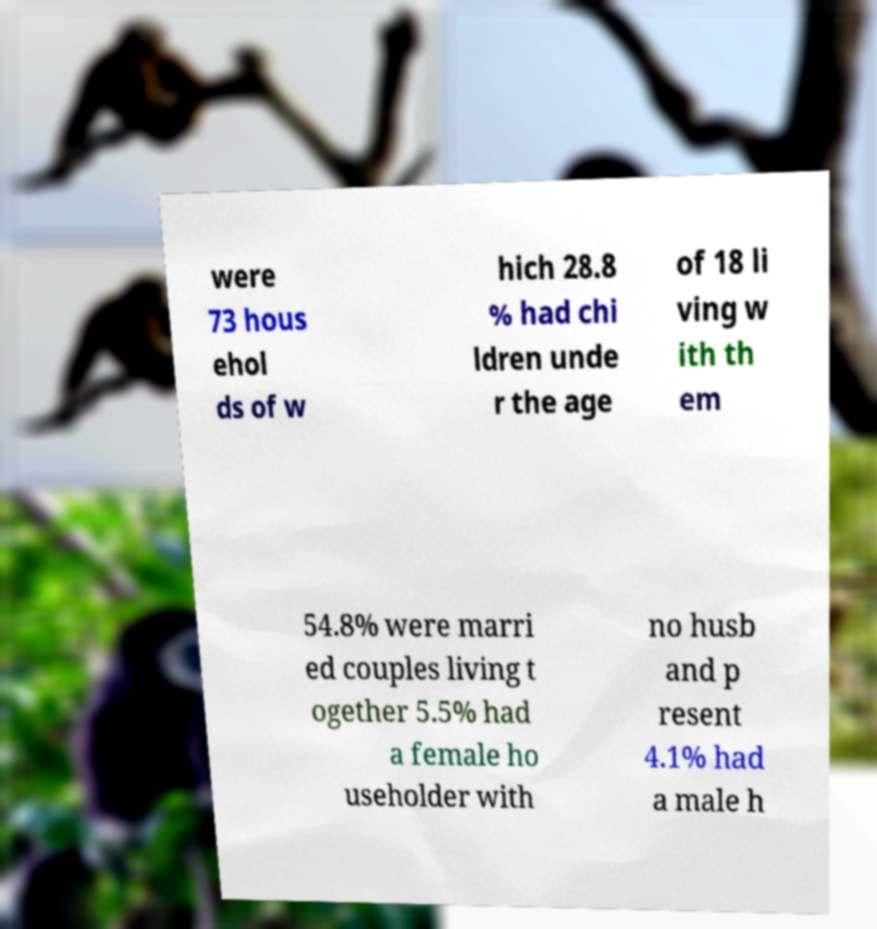Can you accurately transcribe the text from the provided image for me? were 73 hous ehol ds of w hich 28.8 % had chi ldren unde r the age of 18 li ving w ith th em 54.8% were marri ed couples living t ogether 5.5% had a female ho useholder with no husb and p resent 4.1% had a male h 